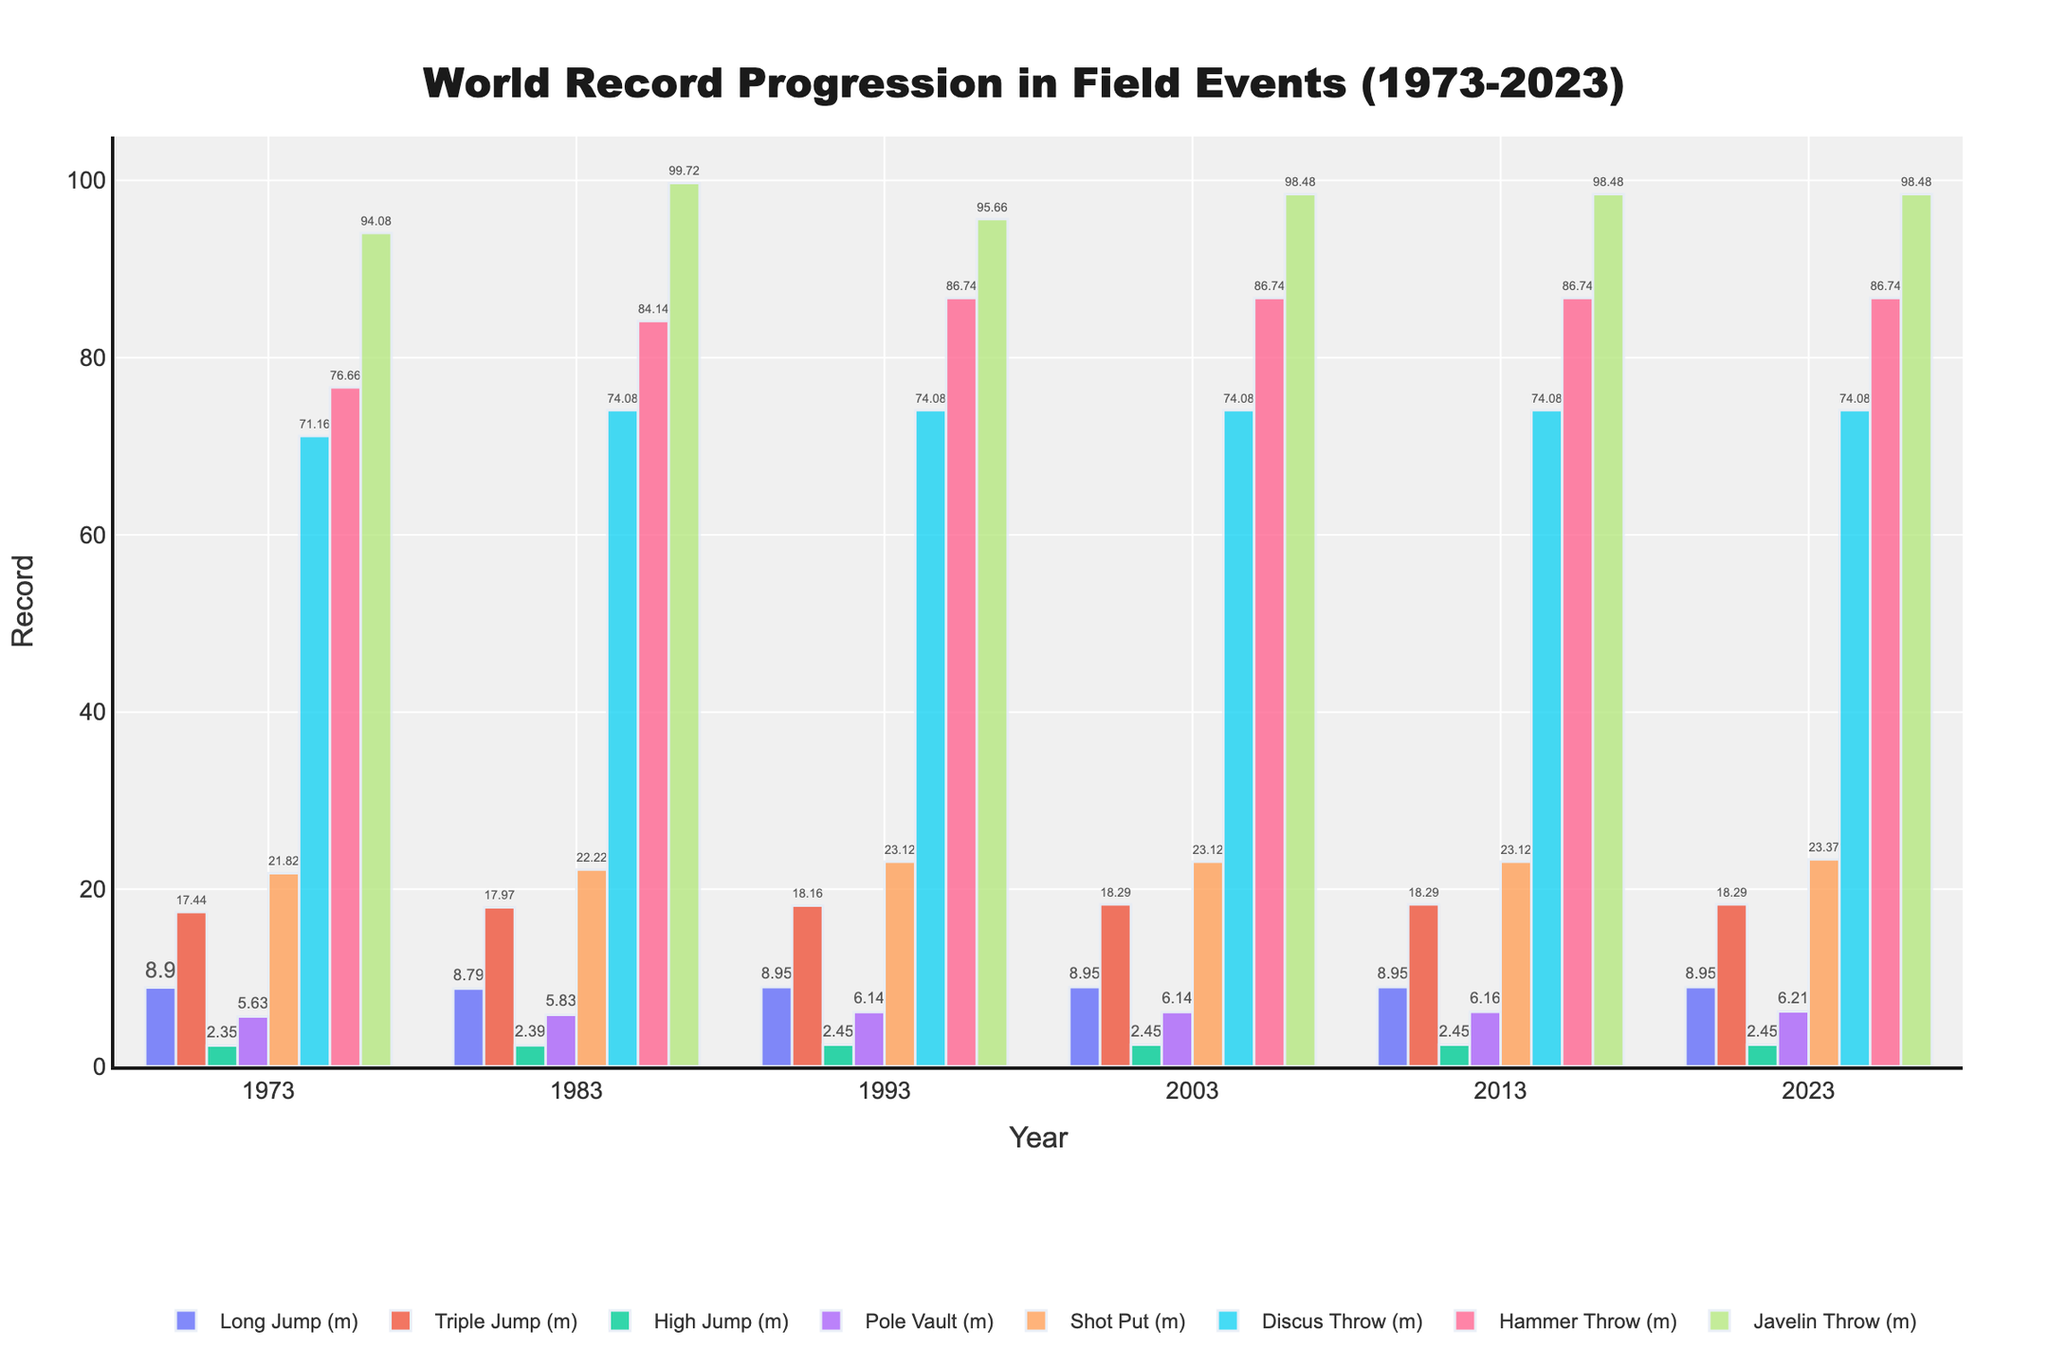what is the world record for the Long Jump event in 2023? Look at the height of the bar for the Long Jump event in 2023 on the chart, you will see 8.95 meters.
Answer: 8.95 meters Which event showed the greatest improvement in its world record from 1973 to 2023? Subtract the 1973 record from the 2023 record for each event and compare the differences. The Pole Vault event shows the largest improvement, increasing from 5.63 meters to 6.21 meters, a 0.58 meters improvement.
Answer: Pole Vault How many events had their world records unchanged between 1993 and 2023? Compare the records of each event in 1993 and 2023. The Long Jump, High Jump, Discus Throw, and Hammer Throw had no changes in their records. This totals to 4 events.
Answer: 4 Which event had the smallest increment in its world record between 1983 and 1993? Calculate the difference between the 1993 and 1983 values for each event and find the smallest difference. The Long Jump has the smallest increment (0.16 meters, from 8.79 meters to 8.95 meters).
Answer: Long Jump Which field event showed a decline in its world record value at any point within the data period? Compare the values for each event year by year to identify any decrease. The Long Jump's record decreased from 8.90 meters in 1973 to 8.79 meters in 1983. The Javelin Throw record also decreased from 99.72 meters in 1983 to 95.66 meters in 1993.
Answer: Long Jump, Javelin Throw In 2003, which event had the highest recorded value? Examine the heights of the bars across all events for 2003. The Javelin Throw had the highest value at 98.48 meters.
Answer: Javelin Throw By how much did the Shot Put world record increase from 1973 to 2023? Subtract the 1973 Shot Put value from the 2023 value, which is 23.37 meters - 21.82 meters = 1.55 meters.
Answer: 1.55 meters What is the average world record value of the High Jump event from 1973 to 2023? Sum the High Jump records from 1973, 1983, 1993, 2003, 2013, and 2023 first: 2.35 + 2.39 + 2.45 + 2.45 + 2.45 + 2.45 = 14.54 meters. Then divide by 6 (number of records): 14.54 / 6 ≈ 2.42 meters.
Answer: 2.42 meters Which event's world record did not change from 1993 to 2013? Compare the 1993 and 2013 records for each event. The Long Jump, High Jump, Discus Throw, and Hammer Throw had no changes during these years.
Answer: Long Jump, High Jump, Discus Throw, Hammer Throw 